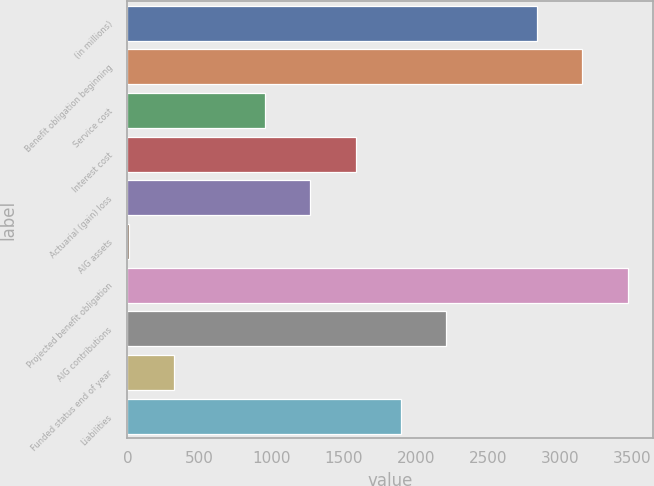<chart> <loc_0><loc_0><loc_500><loc_500><bar_chart><fcel>(in millions)<fcel>Benefit obligation beginning<fcel>Service cost<fcel>Interest cost<fcel>Actuarial (gain) loss<fcel>AIG assets<fcel>Projected benefit obligation<fcel>AIG contributions<fcel>Funded status end of year<fcel>Liabilities<nl><fcel>2841.5<fcel>3156<fcel>954.5<fcel>1583.5<fcel>1269<fcel>11<fcel>3470.5<fcel>2212.5<fcel>325.5<fcel>1898<nl></chart> 